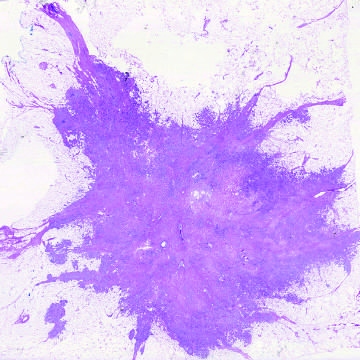how does microscopic view of breast carcinoma illustrate the invasion of breast stroma and fat?
Answer the question using a single word or phrase. By nests and cords of tumor cells 